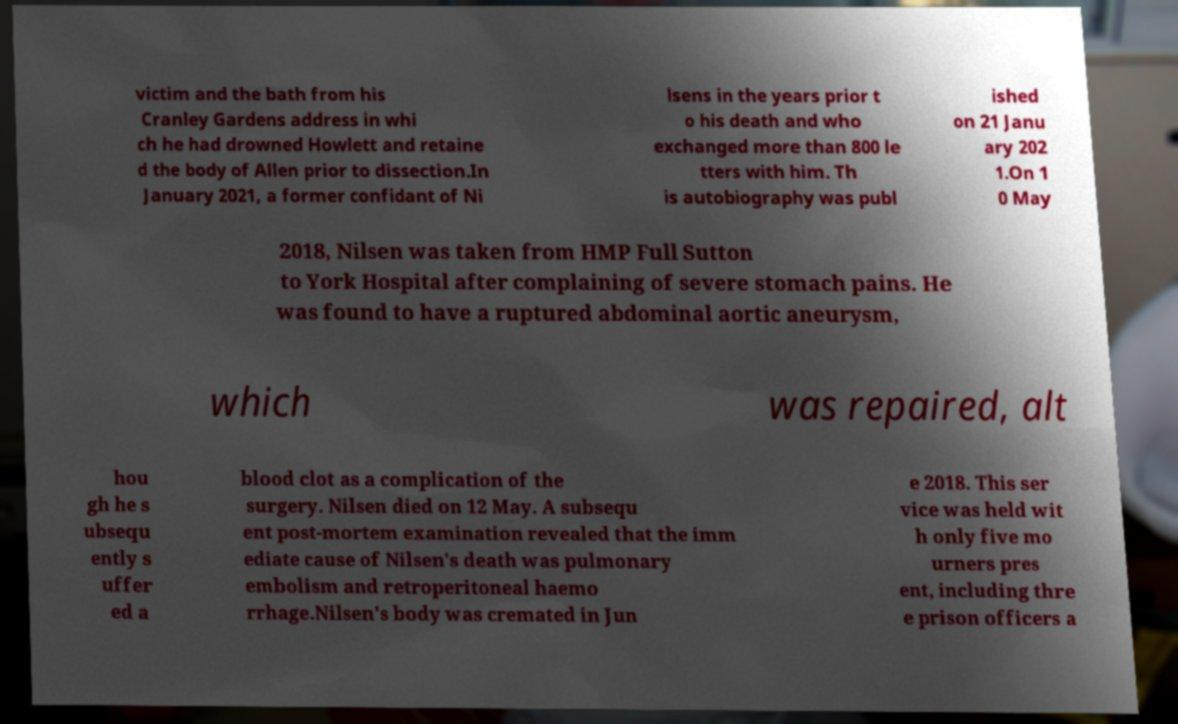Can you accurately transcribe the text from the provided image for me? victim and the bath from his Cranley Gardens address in whi ch he had drowned Howlett and retaine d the body of Allen prior to dissection.In January 2021, a former confidant of Ni lsens in the years prior t o his death and who exchanged more than 800 le tters with him. Th is autobiography was publ ished on 21 Janu ary 202 1.On 1 0 May 2018, Nilsen was taken from HMP Full Sutton to York Hospital after complaining of severe stomach pains. He was found to have a ruptured abdominal aortic aneurysm, which was repaired, alt hou gh he s ubsequ ently s uffer ed a blood clot as a complication of the surgery. Nilsen died on 12 May. A subsequ ent post-mortem examination revealed that the imm ediate cause of Nilsen's death was pulmonary embolism and retroperitoneal haemo rrhage.Nilsen's body was cremated in Jun e 2018. This ser vice was held wit h only five mo urners pres ent, including thre e prison officers a 